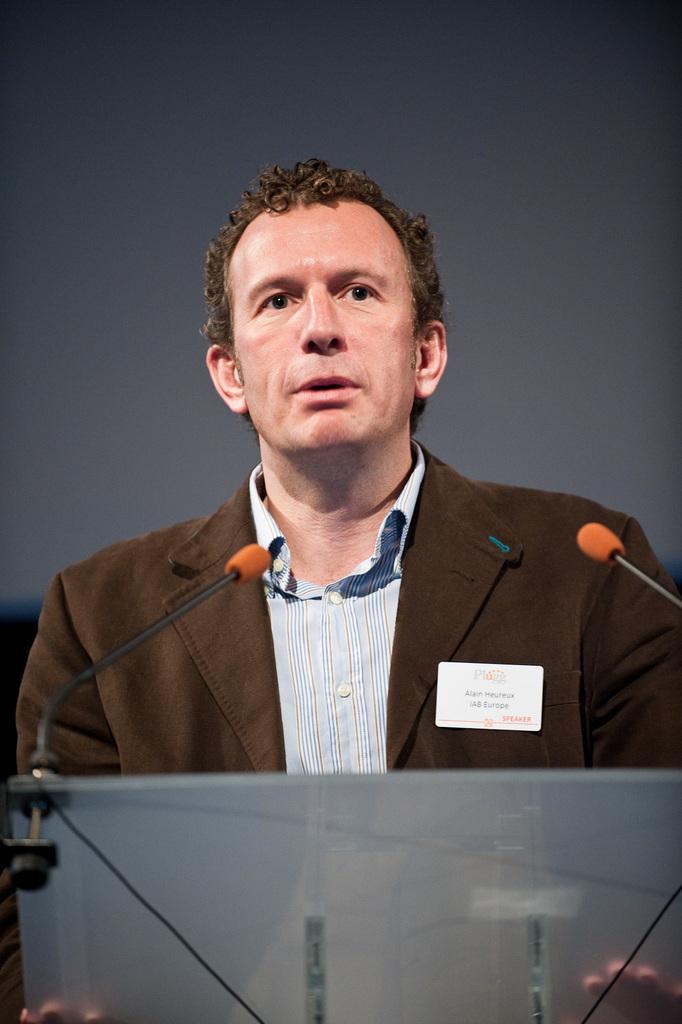How would you summarize this image in a sentence or two? In the foreground of the picture there is a podium, in front of the podium there is a person standing and speaking. In the center there are mics. The background is black. 